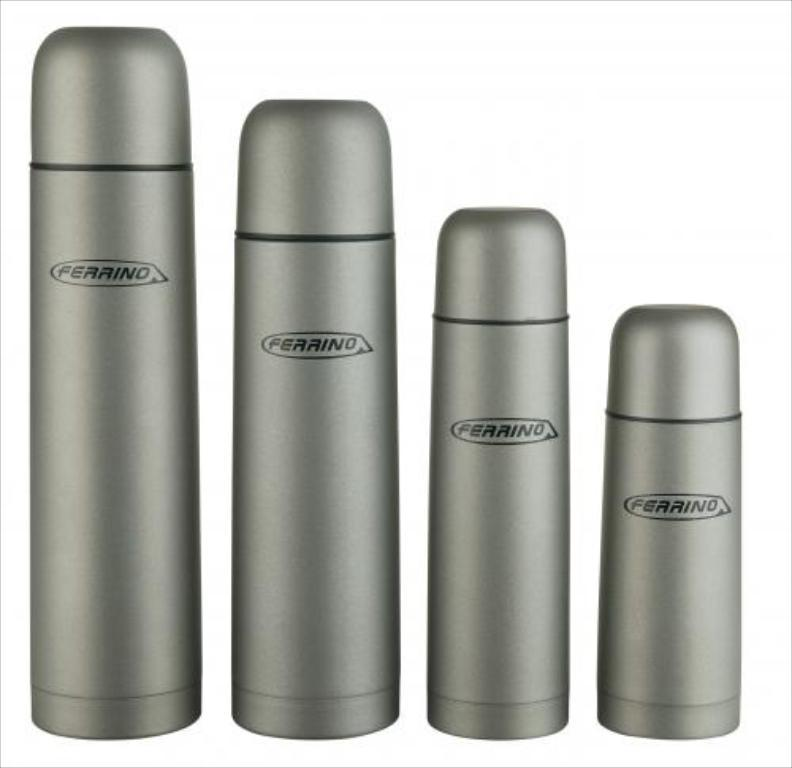<image>
Create a compact narrative representing the image presented. Four canisters of different sizes are labeled with the name Ferrino. 